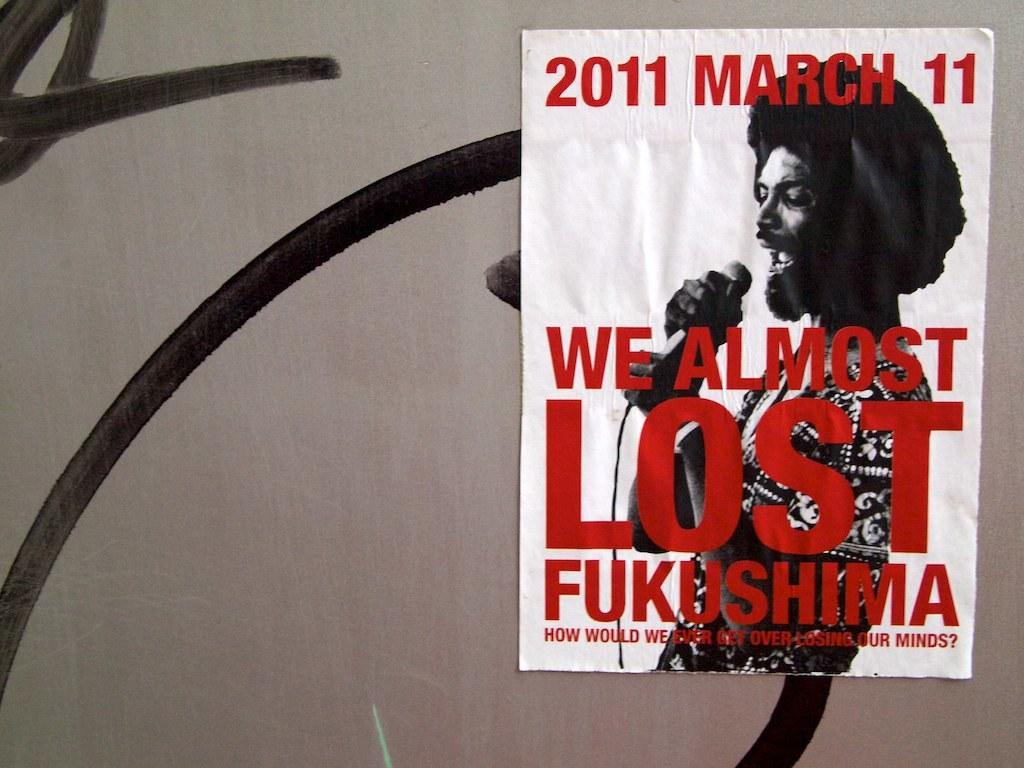<image>
Describe the image concisely. Poster for a concert which takes place on March 11th. 